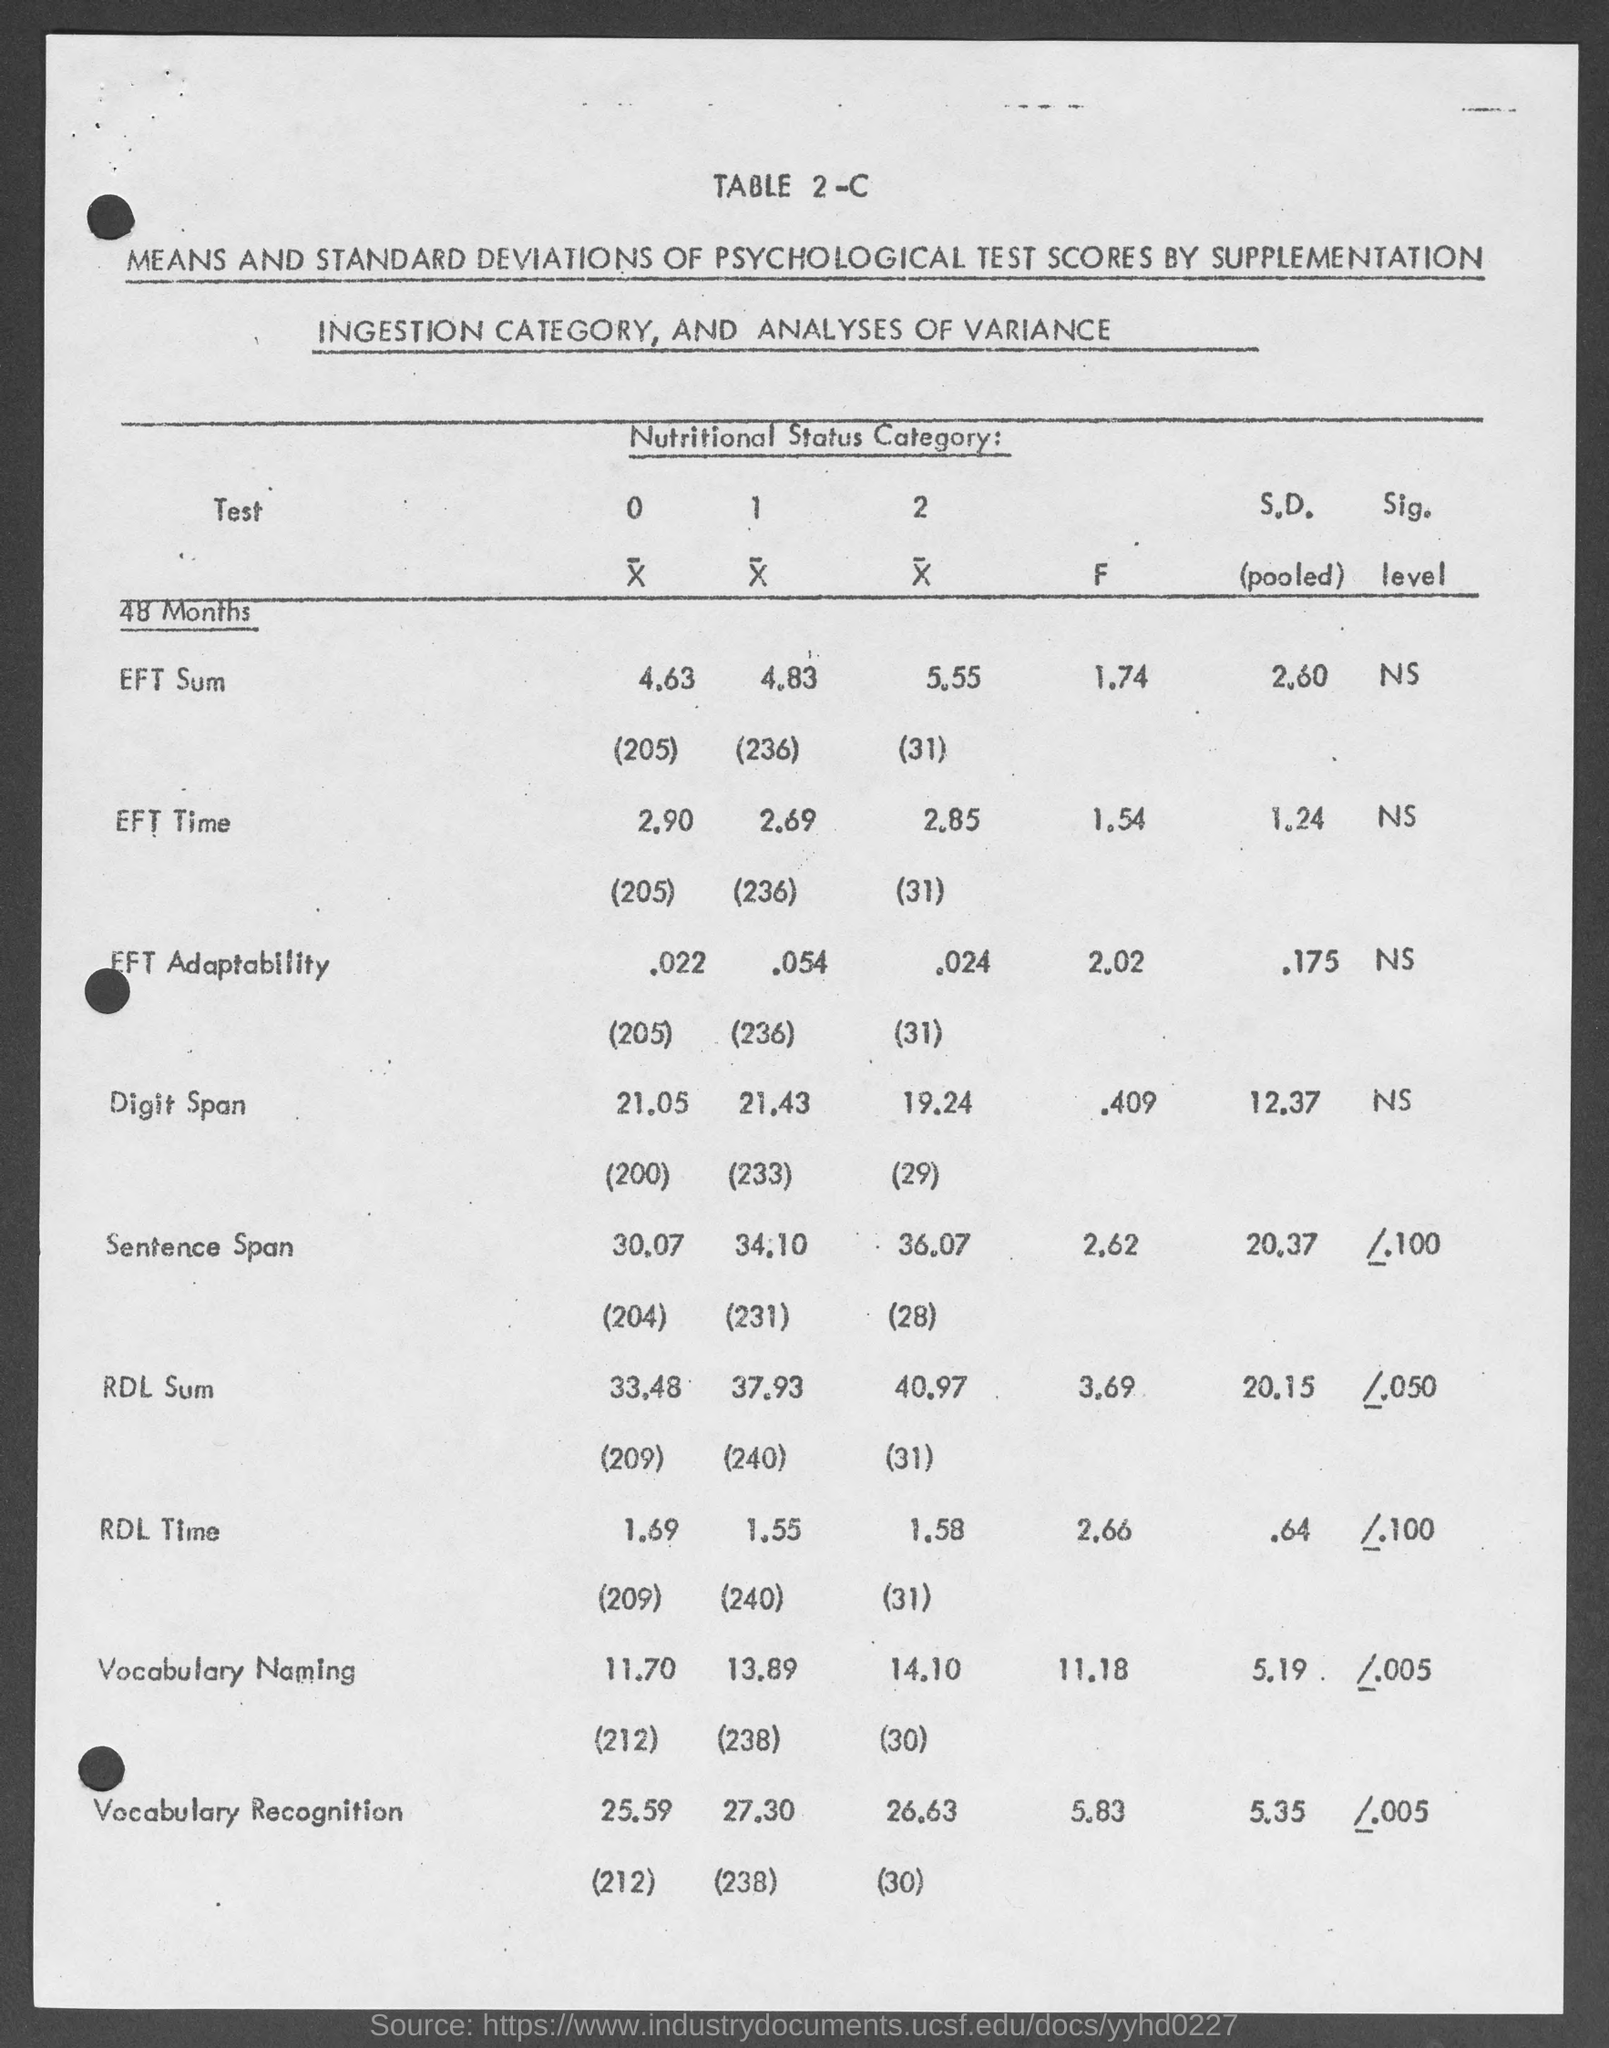Highlight a few significant elements in this photo. The F-value for vocabulary naming is 11.18. The f value for RDL time is 2.66... The F value for Sentence Span is 2.62, indicating that Sentence Span has a moderate effect size. The Digit Span subtest has a mean of 9.50 and a standard deviation of 6.23. The F value for Digit Span is 0.409. The F-value for EFT adaptability is 2.02. 